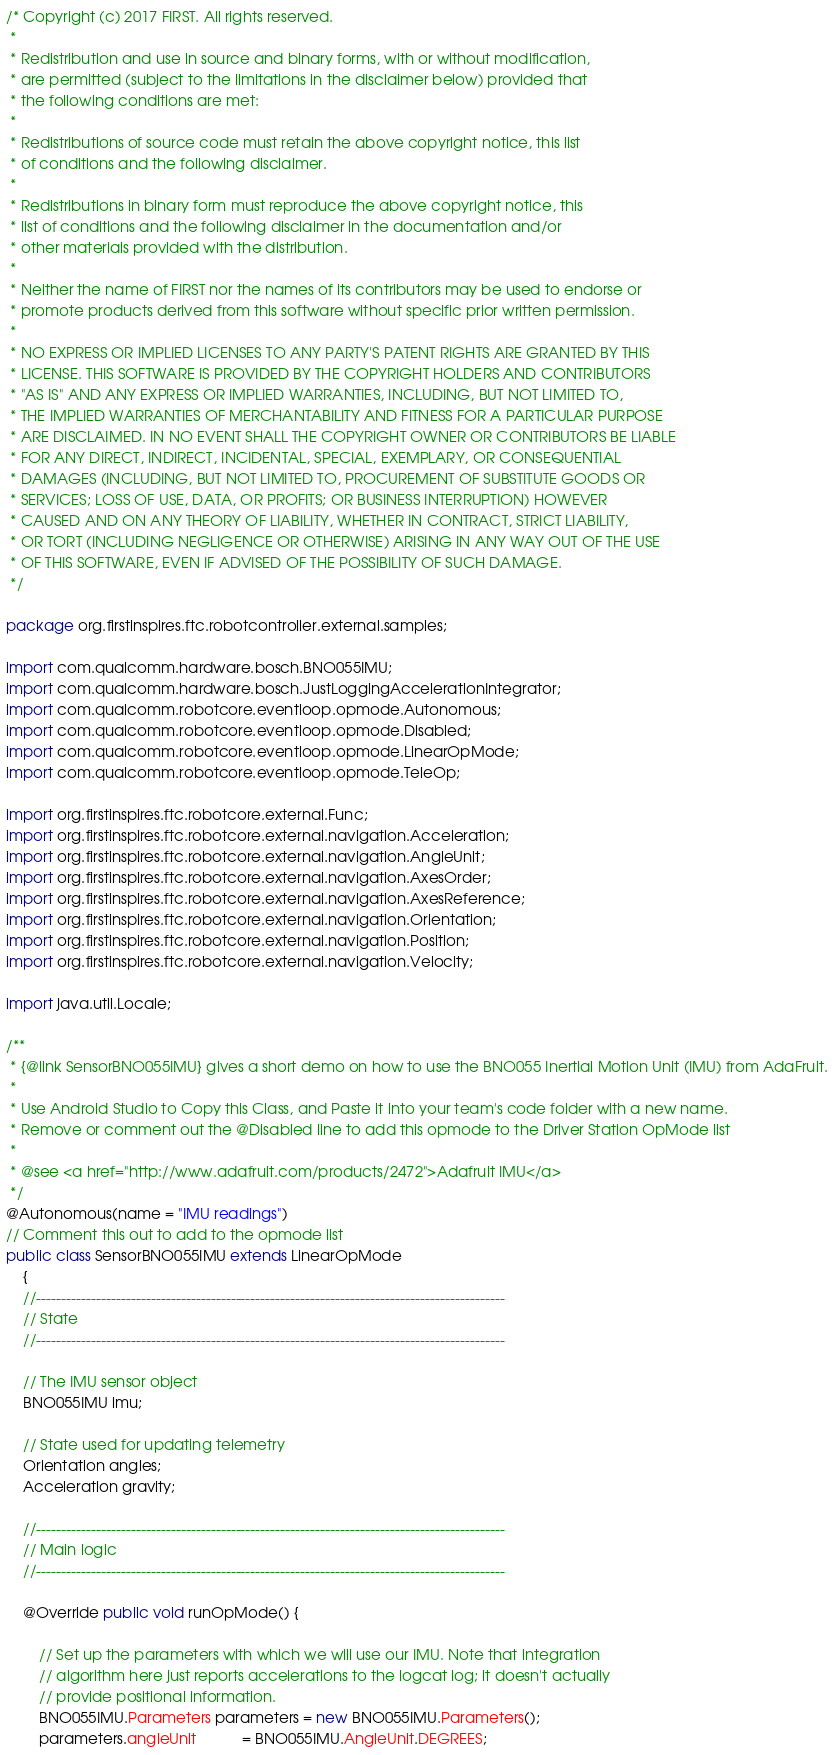<code> <loc_0><loc_0><loc_500><loc_500><_Java_>/* Copyright (c) 2017 FIRST. All rights reserved.
 *
 * Redistribution and use in source and binary forms, with or without modification,
 * are permitted (subject to the limitations in the disclaimer below) provided that
 * the following conditions are met:
 *
 * Redistributions of source code must retain the above copyright notice, this list
 * of conditions and the following disclaimer.
 *
 * Redistributions in binary form must reproduce the above copyright notice, this
 * list of conditions and the following disclaimer in the documentation and/or
 * other materials provided with the distribution.
 *
 * Neither the name of FIRST nor the names of its contributors may be used to endorse or
 * promote products derived from this software without specific prior written permission.
 *
 * NO EXPRESS OR IMPLIED LICENSES TO ANY PARTY'S PATENT RIGHTS ARE GRANTED BY THIS
 * LICENSE. THIS SOFTWARE IS PROVIDED BY THE COPYRIGHT HOLDERS AND CONTRIBUTORS
 * "AS IS" AND ANY EXPRESS OR IMPLIED WARRANTIES, INCLUDING, BUT NOT LIMITED TO,
 * THE IMPLIED WARRANTIES OF MERCHANTABILITY AND FITNESS FOR A PARTICULAR PURPOSE
 * ARE DISCLAIMED. IN NO EVENT SHALL THE COPYRIGHT OWNER OR CONTRIBUTORS BE LIABLE
 * FOR ANY DIRECT, INDIRECT, INCIDENTAL, SPECIAL, EXEMPLARY, OR CONSEQUENTIAL
 * DAMAGES (INCLUDING, BUT NOT LIMITED TO, PROCUREMENT OF SUBSTITUTE GOODS OR
 * SERVICES; LOSS OF USE, DATA, OR PROFITS; OR BUSINESS INTERRUPTION) HOWEVER
 * CAUSED AND ON ANY THEORY OF LIABILITY, WHETHER IN CONTRACT, STRICT LIABILITY,
 * OR TORT (INCLUDING NEGLIGENCE OR OTHERWISE) ARISING IN ANY WAY OUT OF THE USE
 * OF THIS SOFTWARE, EVEN IF ADVISED OF THE POSSIBILITY OF SUCH DAMAGE.
 */

package org.firstinspires.ftc.robotcontroller.external.samples;

import com.qualcomm.hardware.bosch.BNO055IMU;
import com.qualcomm.hardware.bosch.JustLoggingAccelerationIntegrator;
import com.qualcomm.robotcore.eventloop.opmode.Autonomous;
import com.qualcomm.robotcore.eventloop.opmode.Disabled;
import com.qualcomm.robotcore.eventloop.opmode.LinearOpMode;
import com.qualcomm.robotcore.eventloop.opmode.TeleOp;

import org.firstinspires.ftc.robotcore.external.Func;
import org.firstinspires.ftc.robotcore.external.navigation.Acceleration;
import org.firstinspires.ftc.robotcore.external.navigation.AngleUnit;
import org.firstinspires.ftc.robotcore.external.navigation.AxesOrder;
import org.firstinspires.ftc.robotcore.external.navigation.AxesReference;
import org.firstinspires.ftc.robotcore.external.navigation.Orientation;
import org.firstinspires.ftc.robotcore.external.navigation.Position;
import org.firstinspires.ftc.robotcore.external.navigation.Velocity;

import java.util.Locale;

/**
 * {@link SensorBNO055IMU} gives a short demo on how to use the BNO055 Inertial Motion Unit (IMU) from AdaFruit.
 *
 * Use Android Studio to Copy this Class, and Paste it into your team's code folder with a new name.
 * Remove or comment out the @Disabled line to add this opmode to the Driver Station OpMode list
 *
 * @see <a href="http://www.adafruit.com/products/2472">Adafruit IMU</a>
 */
@Autonomous(name = "IMU readings")
// Comment this out to add to the opmode list
public class SensorBNO055IMU extends LinearOpMode
    {
    //----------------------------------------------------------------------------------------------
    // State
    //----------------------------------------------------------------------------------------------

    // The IMU sensor object
    BNO055IMU imu;

    // State used for updating telemetry
    Orientation angles;
    Acceleration gravity;

    //----------------------------------------------------------------------------------------------
    // Main logic
    //----------------------------------------------------------------------------------------------

    @Override public void runOpMode() {

        // Set up the parameters with which we will use our IMU. Note that integration
        // algorithm here just reports accelerations to the logcat log; it doesn't actually
        // provide positional information.
        BNO055IMU.Parameters parameters = new BNO055IMU.Parameters();
        parameters.angleUnit           = BNO055IMU.AngleUnit.DEGREES;</code> 